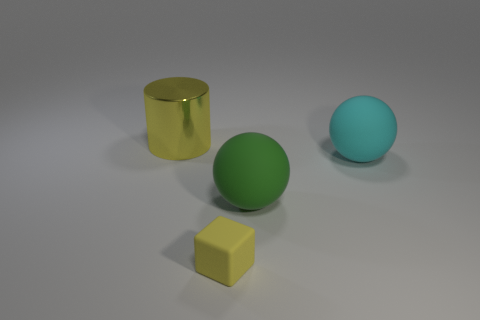Can you describe the objects and their arrangement in the image? The image features three objects placed on a neutral, light-grey surface with a gentle shadow beneath each item. Starting from the left, there's a reflective golden cylinder with a smooth surface, then a matte green sphere, followed by a larger matte cyan sphere. They are positioned in a diagonal line from the front left to the back right of the viewing perspective. 